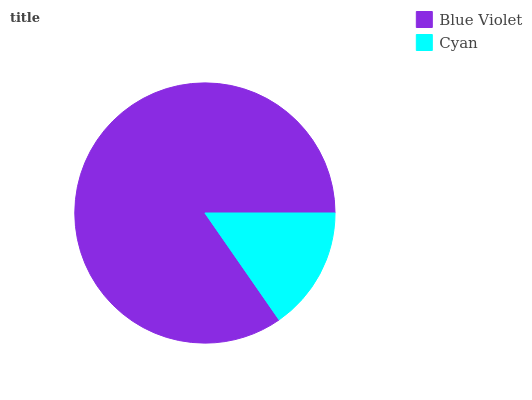Is Cyan the minimum?
Answer yes or no. Yes. Is Blue Violet the maximum?
Answer yes or no. Yes. Is Cyan the maximum?
Answer yes or no. No. Is Blue Violet greater than Cyan?
Answer yes or no. Yes. Is Cyan less than Blue Violet?
Answer yes or no. Yes. Is Cyan greater than Blue Violet?
Answer yes or no. No. Is Blue Violet less than Cyan?
Answer yes or no. No. Is Blue Violet the high median?
Answer yes or no. Yes. Is Cyan the low median?
Answer yes or no. Yes. Is Cyan the high median?
Answer yes or no. No. Is Blue Violet the low median?
Answer yes or no. No. 